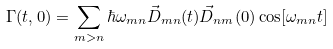Convert formula to latex. <formula><loc_0><loc_0><loc_500><loc_500>\Gamma ( t , 0 ) = \sum _ { m > n } { \hbar { \omega } _ { m n } \vec { D } _ { m n } ( t ) \vec { D } _ { n m } ( 0 ) \cos [ \omega _ { m n } t ] }</formula> 